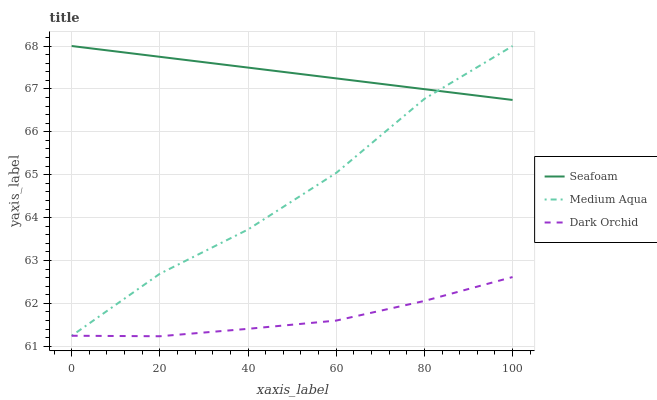Does Dark Orchid have the minimum area under the curve?
Answer yes or no. Yes. Does Seafoam have the maximum area under the curve?
Answer yes or no. Yes. Does Seafoam have the minimum area under the curve?
Answer yes or no. No. Does Dark Orchid have the maximum area under the curve?
Answer yes or no. No. Is Seafoam the smoothest?
Answer yes or no. Yes. Is Medium Aqua the roughest?
Answer yes or no. Yes. Is Dark Orchid the smoothest?
Answer yes or no. No. Is Dark Orchid the roughest?
Answer yes or no. No. Does Dark Orchid have the lowest value?
Answer yes or no. Yes. Does Seafoam have the lowest value?
Answer yes or no. No. Does Seafoam have the highest value?
Answer yes or no. Yes. Does Dark Orchid have the highest value?
Answer yes or no. No. Is Dark Orchid less than Seafoam?
Answer yes or no. Yes. Is Seafoam greater than Dark Orchid?
Answer yes or no. Yes. Does Medium Aqua intersect Dark Orchid?
Answer yes or no. Yes. Is Medium Aqua less than Dark Orchid?
Answer yes or no. No. Is Medium Aqua greater than Dark Orchid?
Answer yes or no. No. Does Dark Orchid intersect Seafoam?
Answer yes or no. No. 